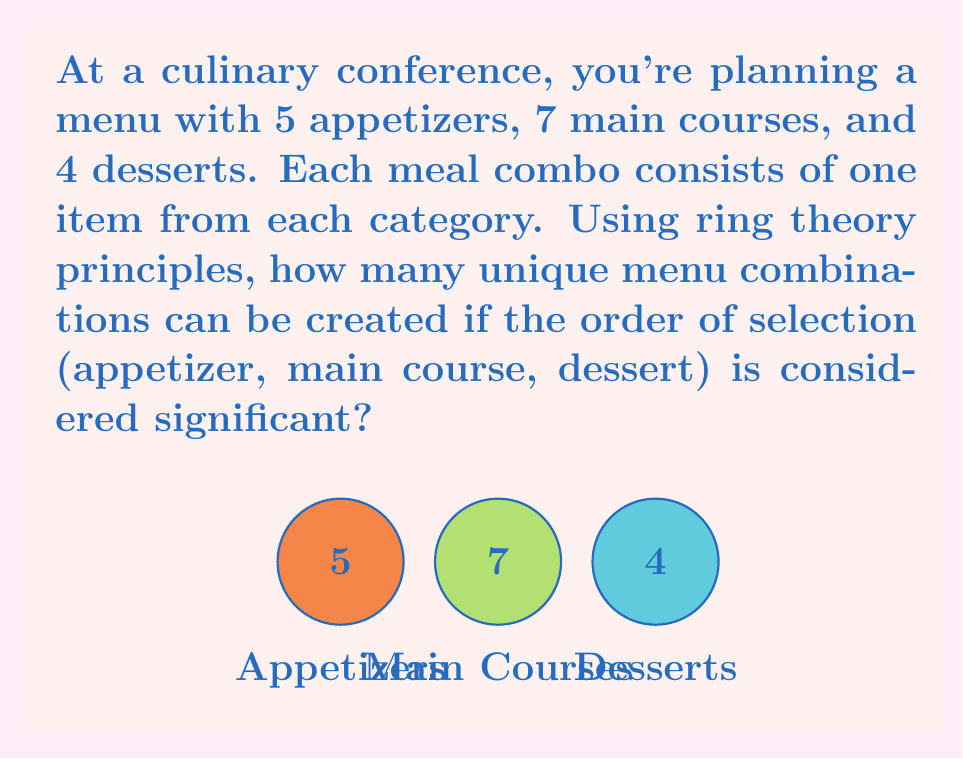Help me with this question. To solve this problem using ring theory principles, we can consider each category (appetizers, main courses, and desserts) as a cyclic group under rotation. The number of unique combinations can be found by applying the multiplication principle in ring theory.

Step 1: Identify the order of each cyclic group
- Appetizers: $|C_5| = 5$
- Main Courses: $|C_7| = 7$
- Desserts: $|C_4| = 4$

Step 2: Apply the multiplication principle
In ring theory, when we combine elements from different cyclic groups, the total number of combinations is the product of the orders of these groups. This is because each choice from one group can be paired with every choice from the other groups.

Therefore, the total number of unique menu combinations is:

$$|C_5| \times |C_7| \times |C_4| = 5 \times 7 \times 4$$

Step 3: Calculate the result
$$5 \times 7 \times 4 = 140$$

This result represents the number of unique menu combinations, considering the order of selection as significant. Each combination uniquely represents a specific choice of appetizer, main course, and dessert in that order.
Answer: 140 unique menu combinations 